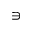<formula> <loc_0><loc_0><loc_500><loc_500>\ni</formula> 